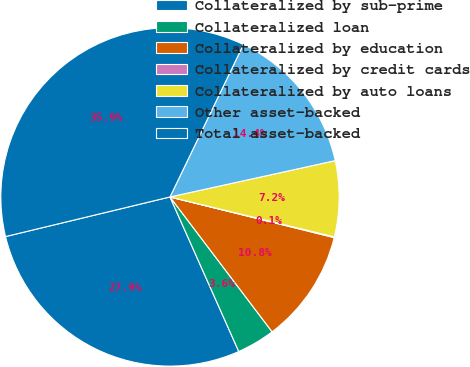Convert chart. <chart><loc_0><loc_0><loc_500><loc_500><pie_chart><fcel>Collateralized by sub-prime<fcel>Collateralized loan<fcel>Collateralized by education<fcel>Collateralized by credit cards<fcel>Collateralized by auto loans<fcel>Other asset-backed<fcel>Total asset-backed<nl><fcel>27.9%<fcel>3.65%<fcel>10.82%<fcel>0.07%<fcel>7.24%<fcel>14.41%<fcel>35.91%<nl></chart> 